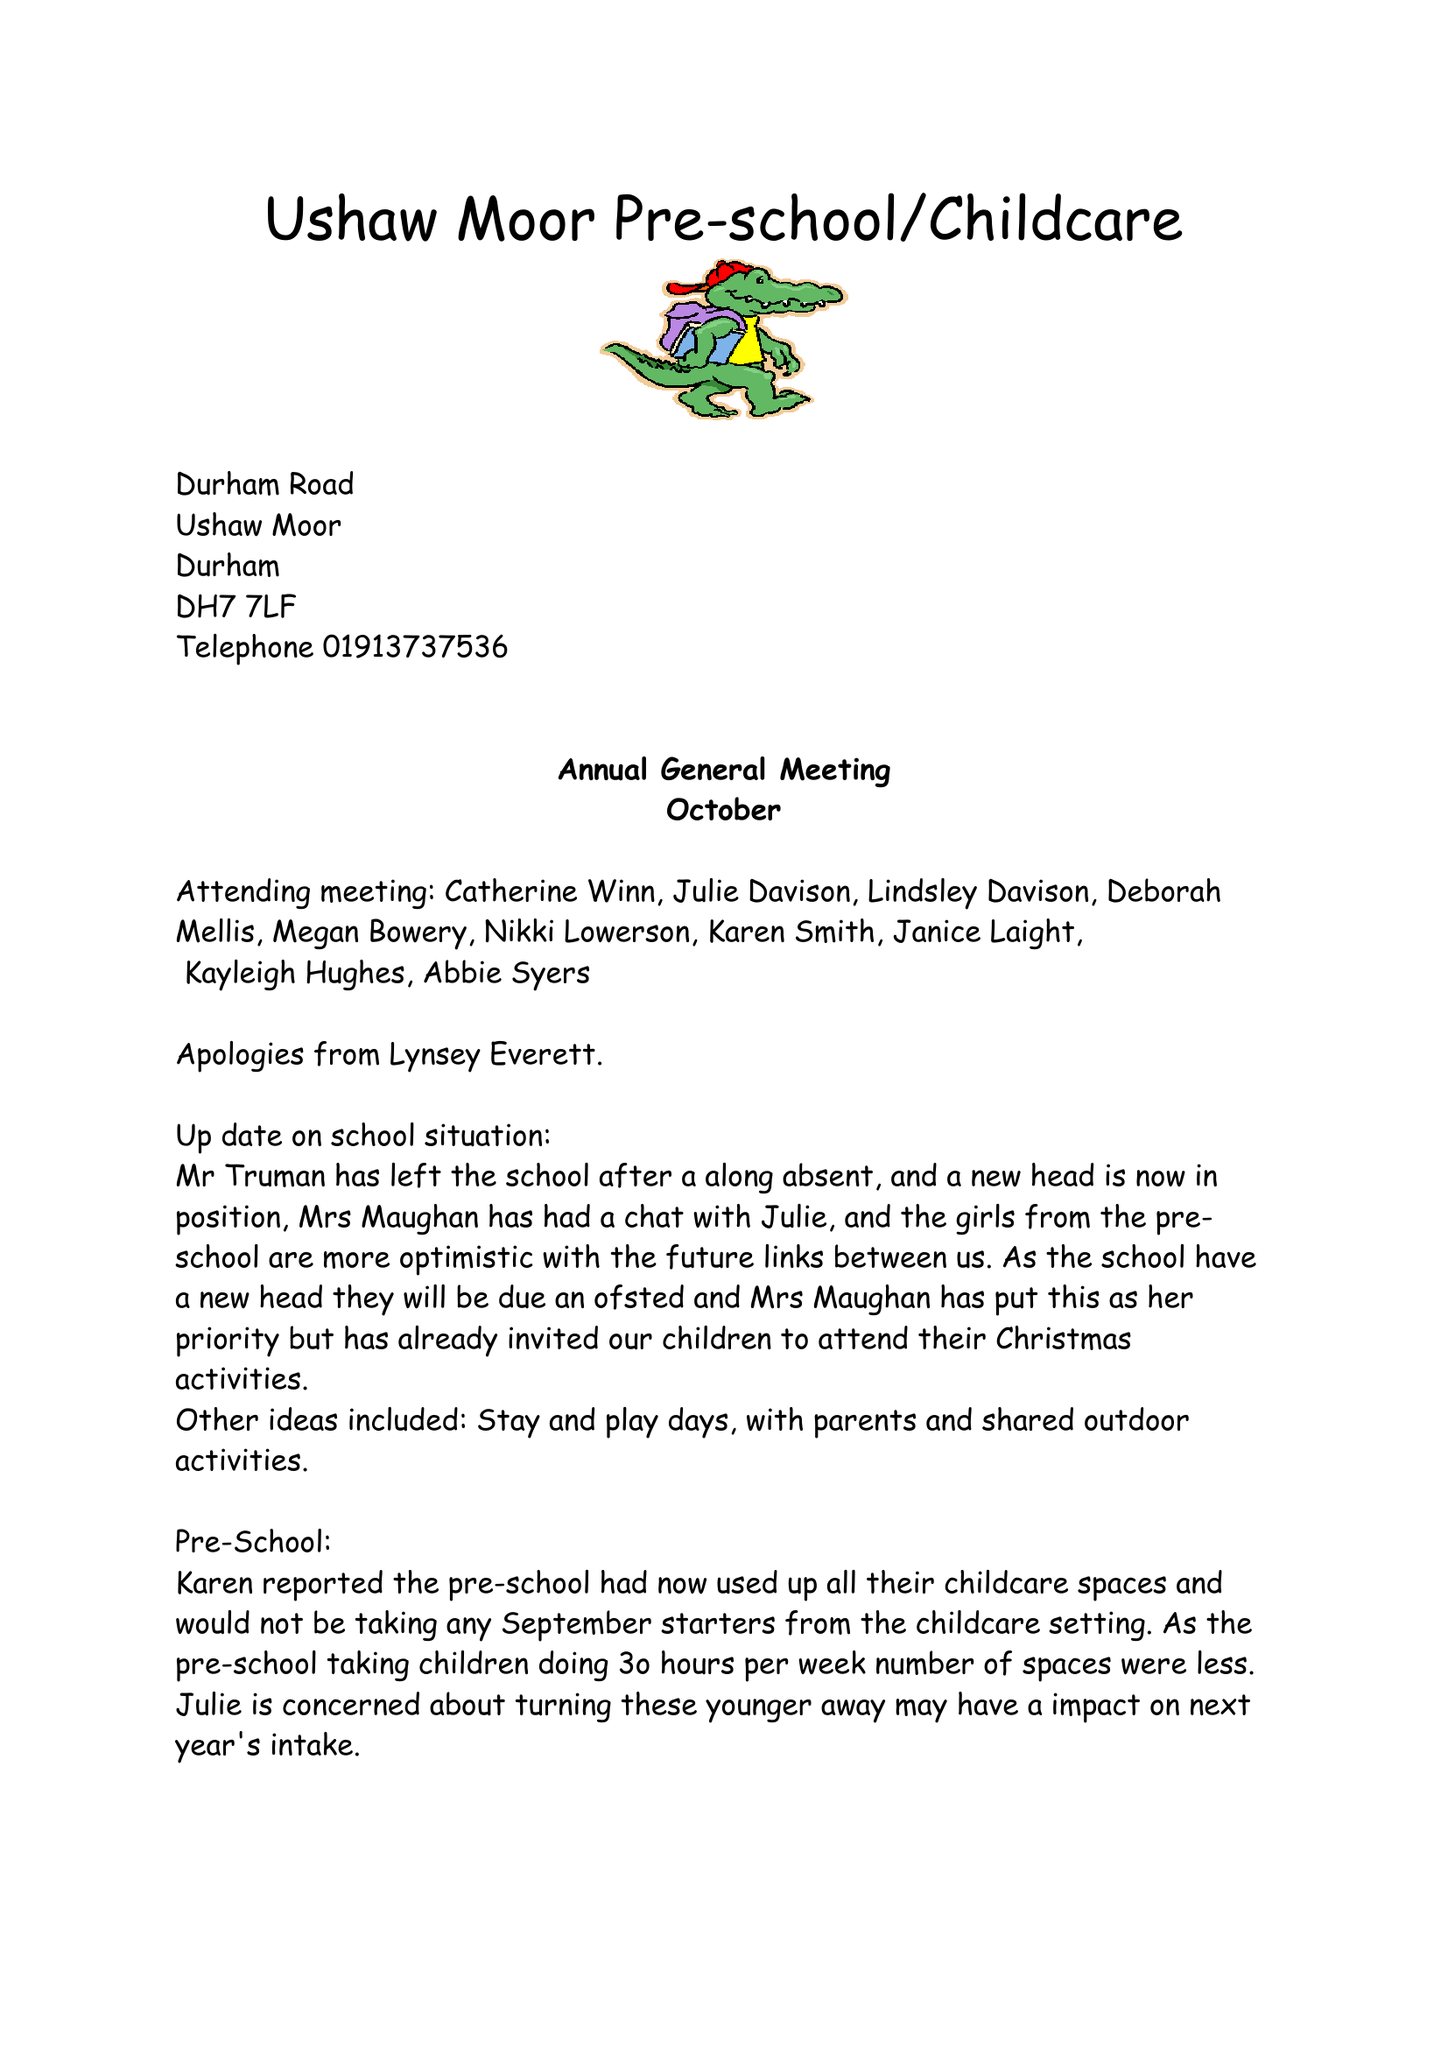What is the value for the address__post_town?
Answer the question using a single word or phrase. DURHAM 